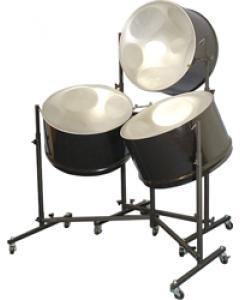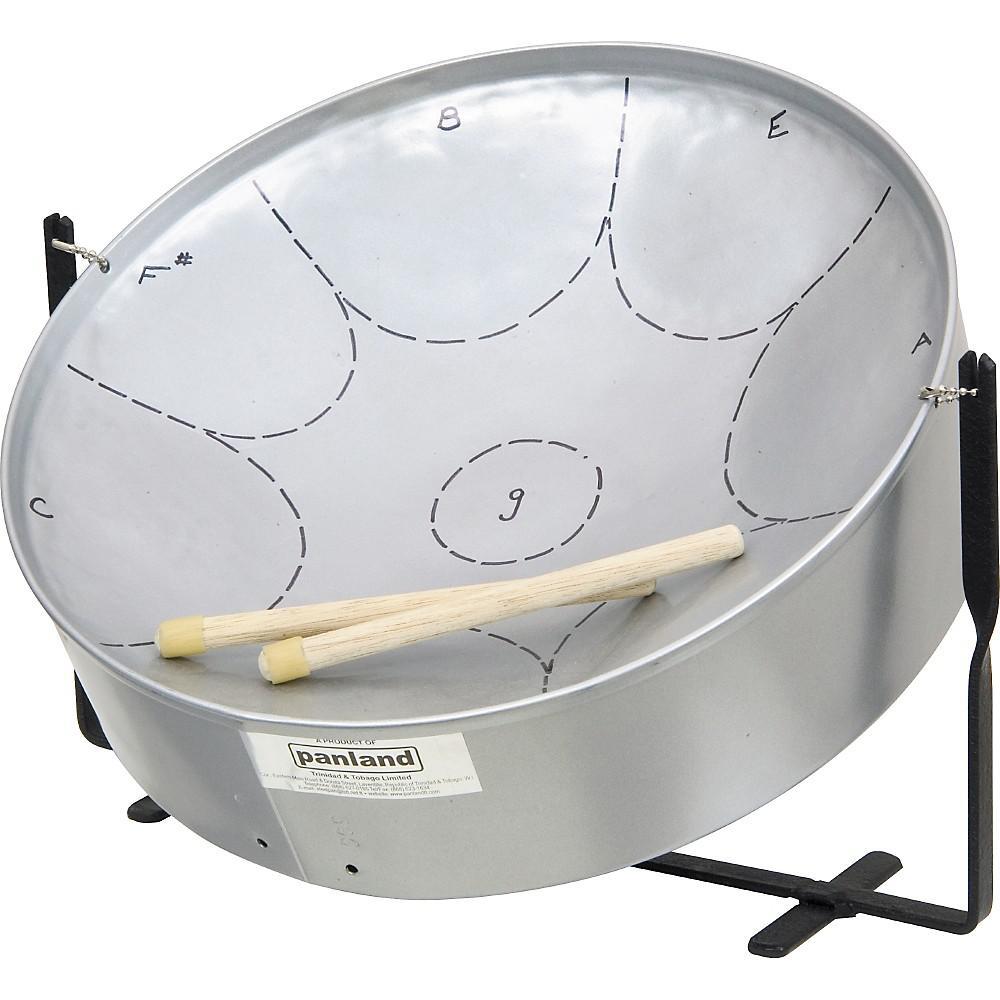The first image is the image on the left, the second image is the image on the right. Evaluate the accuracy of this statement regarding the images: "Each image shows one cylindrical metal drum with a concave top, and the drums on the right and left have similar shaped stands.". Is it true? Answer yes or no. No. The first image is the image on the left, the second image is the image on the right. Considering the images on both sides, is "Exactly two drums are attached to floor stands, which are different, but with the same style of feet." valid? Answer yes or no. No. 